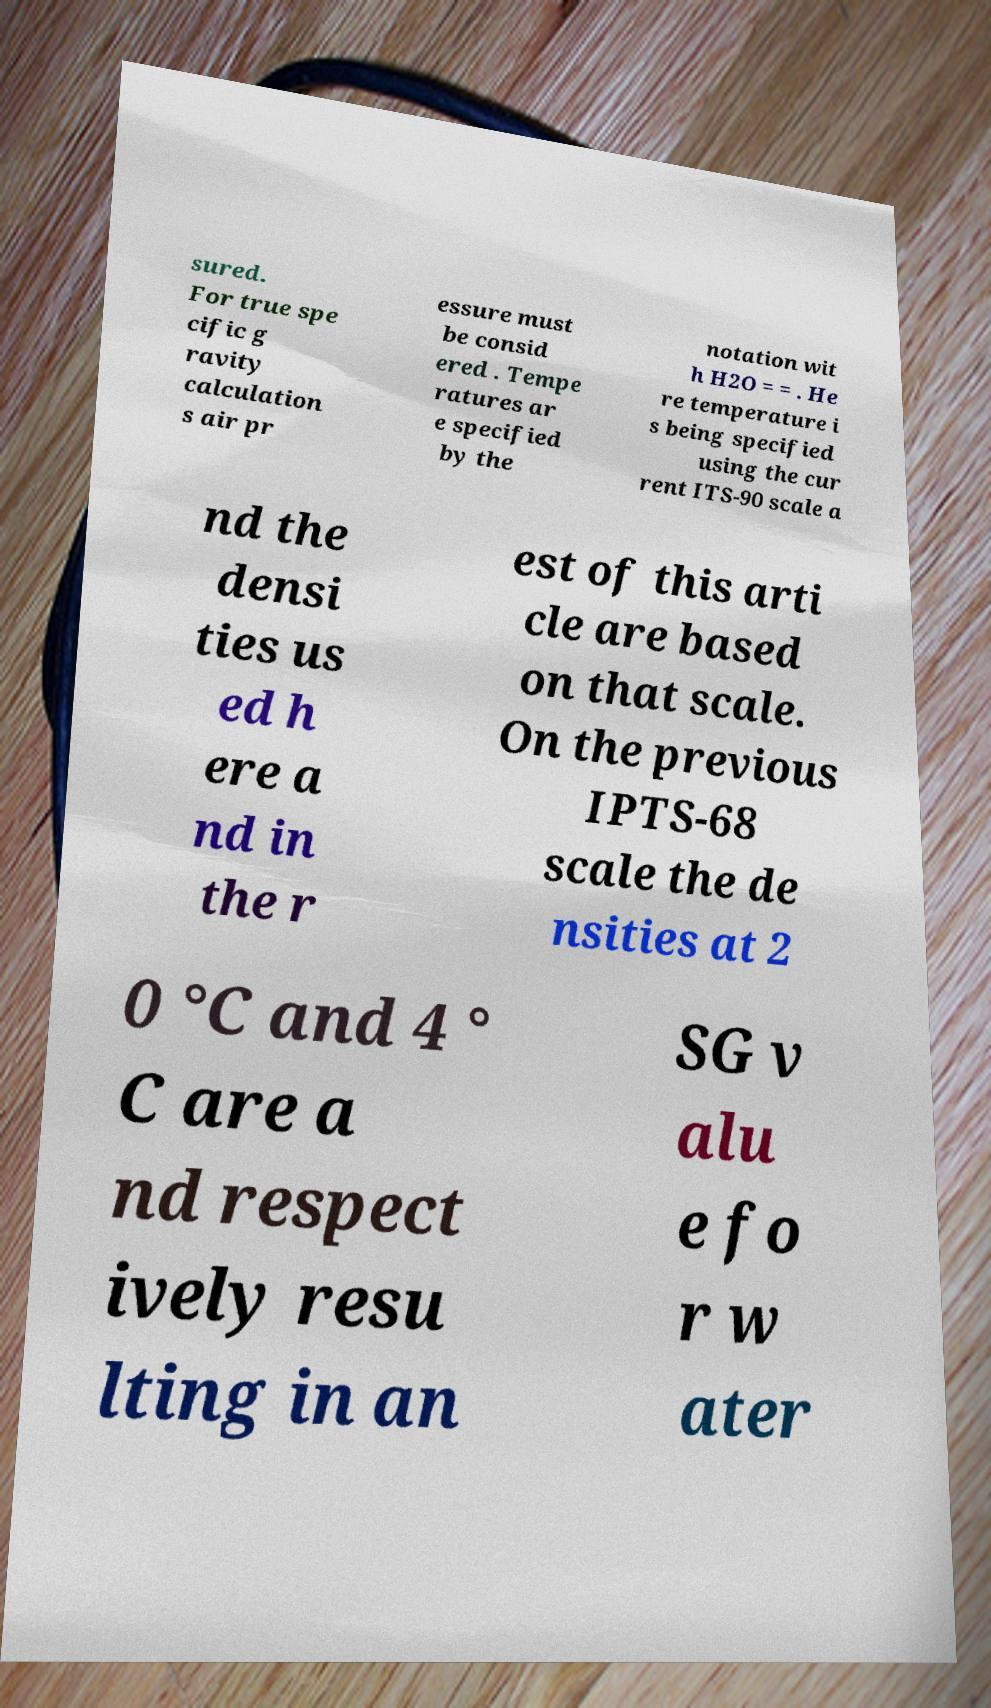Could you assist in decoding the text presented in this image and type it out clearly? sured. For true spe cific g ravity calculation s air pr essure must be consid ered . Tempe ratures ar e specified by the notation wit h H2O = = . He re temperature i s being specified using the cur rent ITS-90 scale a nd the densi ties us ed h ere a nd in the r est of this arti cle are based on that scale. On the previous IPTS-68 scale the de nsities at 2 0 °C and 4 ° C are a nd respect ively resu lting in an SG v alu e fo r w ater 